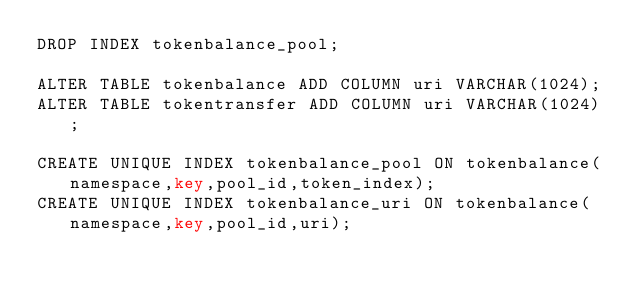Convert code to text. <code><loc_0><loc_0><loc_500><loc_500><_SQL_>DROP INDEX tokenbalance_pool;

ALTER TABLE tokenbalance ADD COLUMN uri VARCHAR(1024);
ALTER TABLE tokentransfer ADD COLUMN uri VARCHAR(1024);

CREATE UNIQUE INDEX tokenbalance_pool ON tokenbalance(namespace,key,pool_id,token_index);
CREATE UNIQUE INDEX tokenbalance_uri ON tokenbalance(namespace,key,pool_id,uri);
</code> 